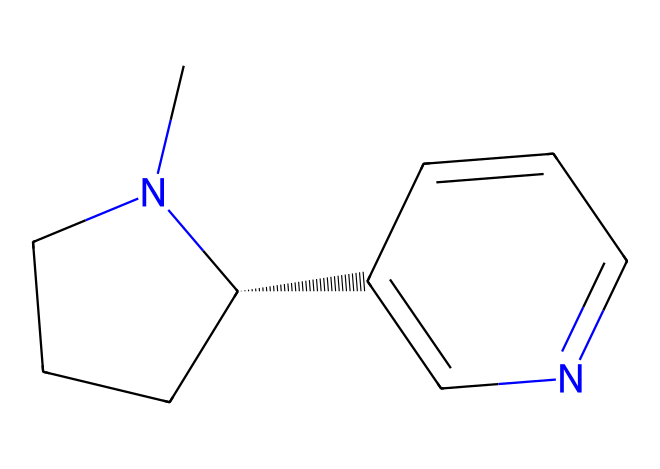What is the primary functional group present in nicotine? The chemical structure contains nitrogen atoms, which are characteristic of the amine functional group, specifically a tertiary amine. This is inferred from the presence of the nitrogen atom connected to three carbon atoms.
Answer: tertiary amine How many carbon atoms are present in the nicotine structure? By analyzing the SMILES representation, we can count the number of carbon atoms represented in the structure. There are a total of ten carbon atoms (C) in the structure provided.
Answer: ten What type of compound is nicotine classified as? Nicotine has a complex structure, primarily consisting of carbon and nitrogen atoms, which classifies it as an alkaloid, a basic nitrogen-containing compound derived from plants.
Answer: alkaloid What is the stereochemistry of the carbon at the 5-position in nicotine? The stereochemistry around the carbon at the 5-position is indicated by the "@" symbol in the SMILES notation, which shows that this carbon center is chiral and exists in a specific spatial arrangement.
Answer: chiral How many rings are present in the nicotine structure? Observing the structure, it is clear that nicotine has two rings. The first ring is a piperidine ring, and the second is a pyridine ring, making a total of two fused rings.
Answer: two 